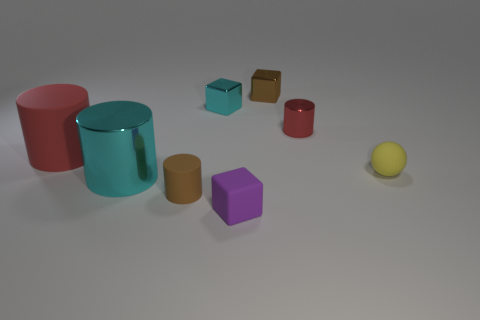Is the material of the yellow ball the same as the small brown thing behind the ball?
Provide a short and direct response. No. Does the brown rubber thing have the same shape as the red rubber object?
Your response must be concise. Yes. What is the material of the small brown thing that is the same shape as the tiny purple thing?
Ensure brevity in your answer.  Metal. There is a rubber object that is to the left of the tiny matte block and in front of the big cyan metallic thing; what color is it?
Offer a terse response. Brown. What is the color of the large rubber cylinder?
Your answer should be compact. Red. What material is the other cylinder that is the same color as the tiny metallic cylinder?
Your response must be concise. Rubber. Is there a tiny brown matte thing of the same shape as the red shiny thing?
Your response must be concise. Yes. What is the size of the matte thing that is in front of the tiny brown cylinder?
Make the answer very short. Small. There is another cyan cube that is the same size as the rubber cube; what material is it?
Provide a succinct answer. Metal. Are there more small brown shiny spheres than large cyan objects?
Provide a succinct answer. No. 